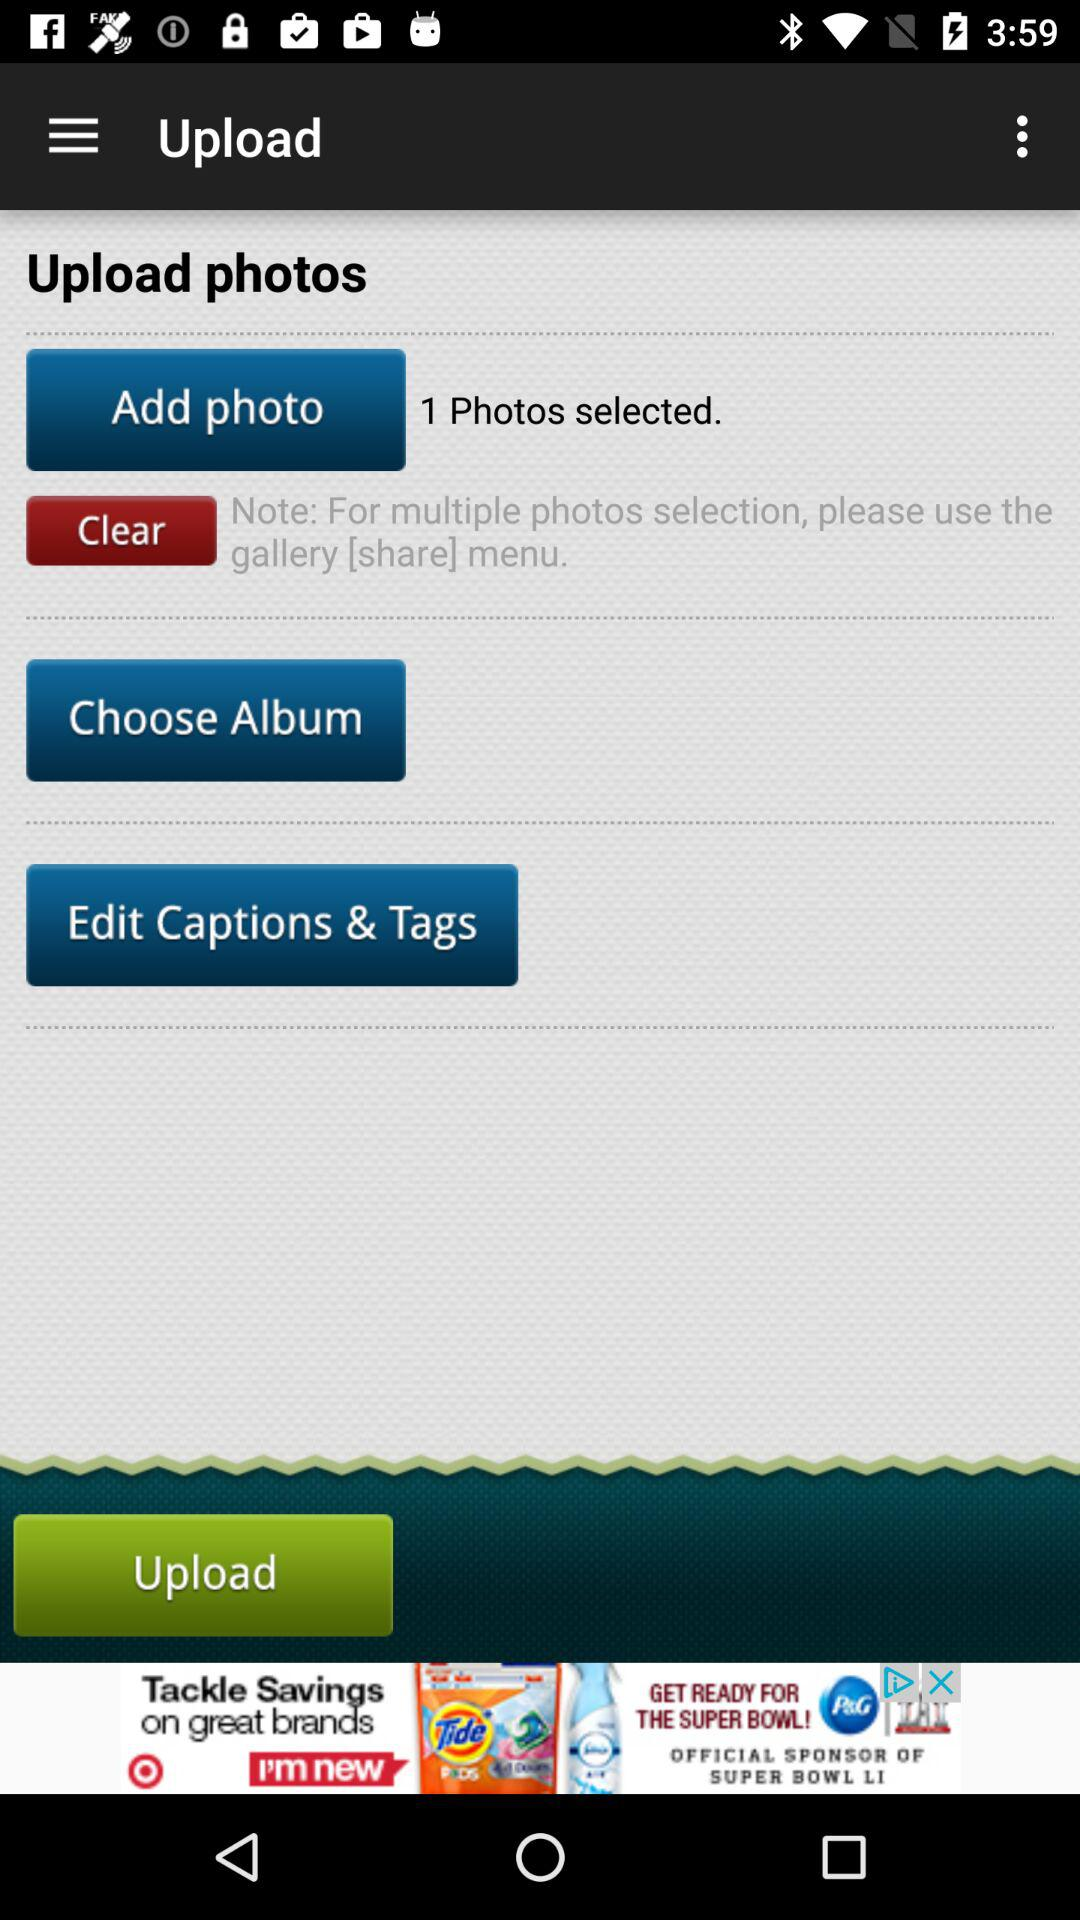How many photos are selected? The selected photo is 1. 